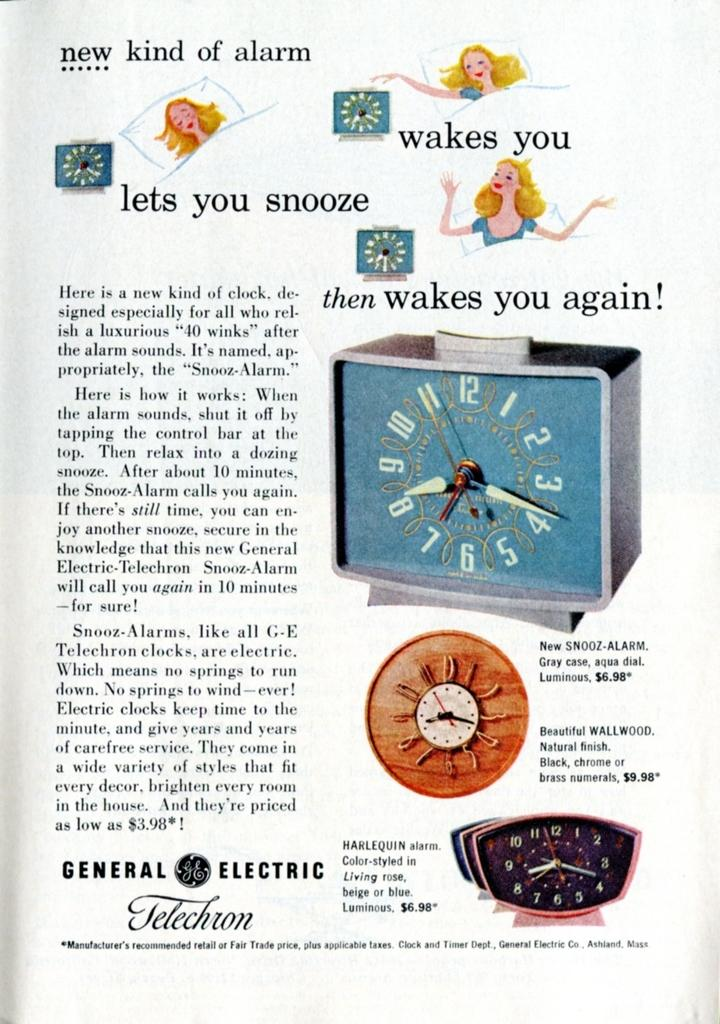<image>
Summarize the visual content of the image. A picture of an advertisements that says New Kind of Alarm. 